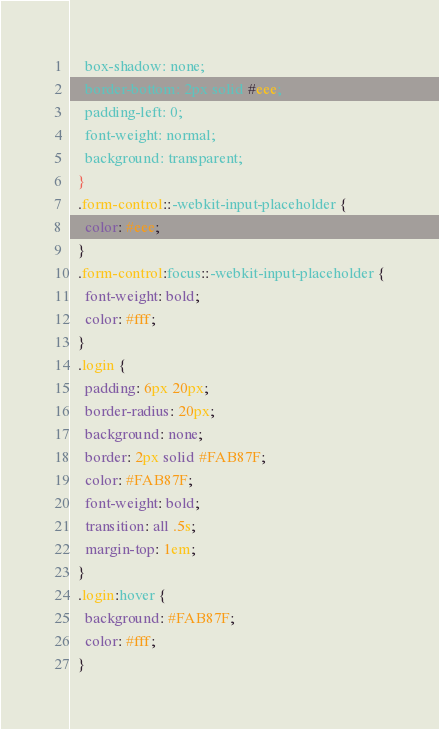<code> <loc_0><loc_0><loc_500><loc_500><_CSS_>    box-shadow: none;
    border-bottom: 2px solid #eee;
    padding-left: 0;
    font-weight: normal;
    background: transparent;  
  }
  .form-control::-webkit-input-placeholder {
    color: #eee;  
  }
  .form-control:focus::-webkit-input-placeholder {
    font-weight: bold;
    color: #fff;
  }
  .login {
    padding: 6px 20px;
    border-radius: 20px;
    background: none;
    border: 2px solid #FAB87F;
    color: #FAB87F;
    font-weight: bold;
    transition: all .5s;
    margin-top: 1em;
  }
  .login:hover {
    background: #FAB87F;
    color: #fff;
  }</code> 